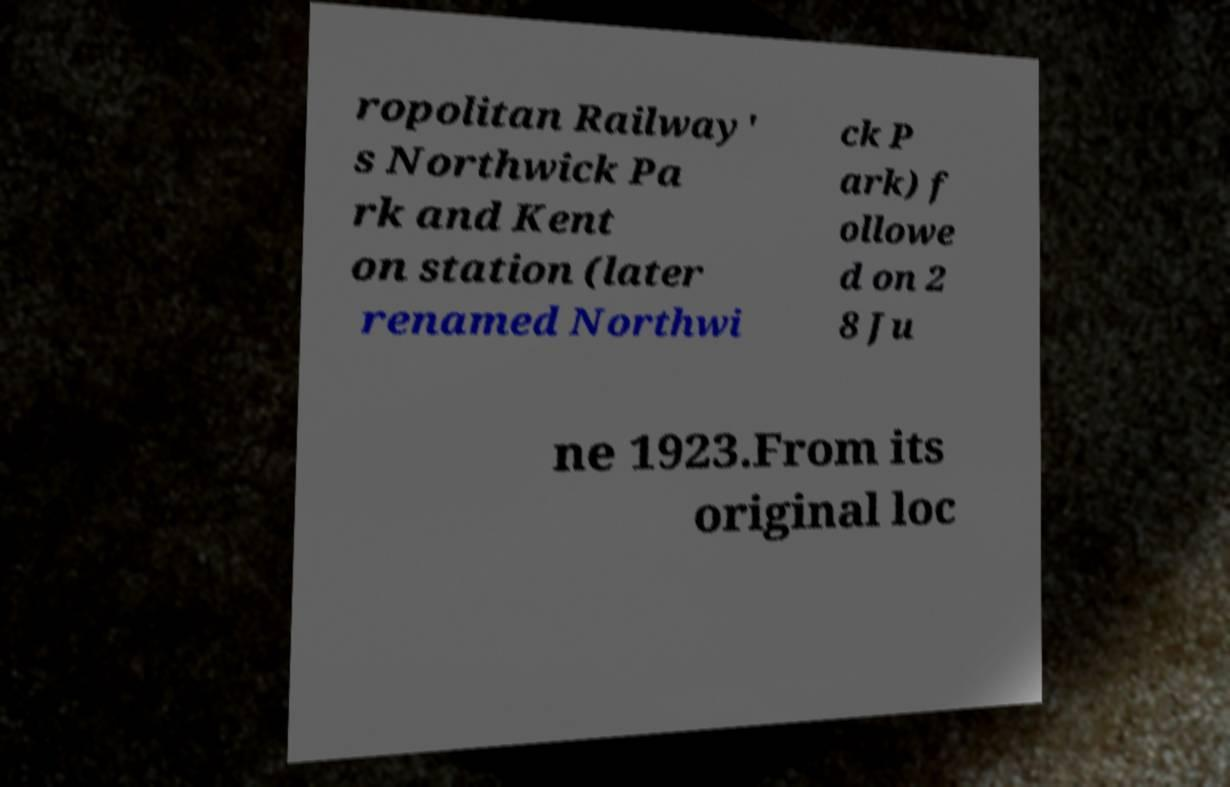For documentation purposes, I need the text within this image transcribed. Could you provide that? ropolitan Railway' s Northwick Pa rk and Kent on station (later renamed Northwi ck P ark) f ollowe d on 2 8 Ju ne 1923.From its original loc 